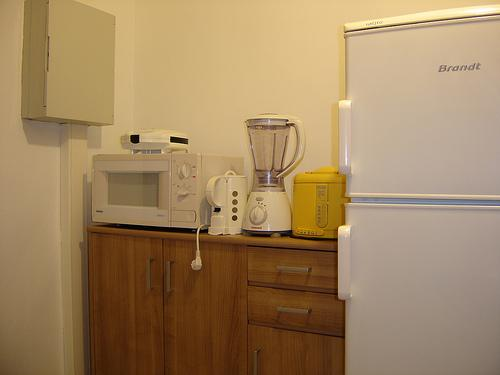Identify three colors prominently found in the image. White, brown, and tan (beige). Describe the appearance and features of the cabinets in the image. The cabinets are brown with drawers and doors, having two white nicely turned handles, and metal handles on the drawers. Tell me about the electrical items associated with the devices in the kitchen. There is a hanging electrical cord, a white cord and plug, a CEE Euro standard plug cable, and a power supply box. Name the appliance on top of the microwave and guess its purpose. A spaceship-shaped waffle maker presumably used for making crepes or waffles. Explain the position of the microwave and blender in relation to each other. The microwave is situated on the countertop, and the blender is next to it on the same countertop. Give a brief summary of the objects in the image, including their colors and arrangement. There are various kitchen appliances such as a white refrigerator, microwave, blender, and coffeemaker; brown cabinets and drawers; a beige-colored wall; a tan electrical box, and a waffle maker on top of the microwave. They are arranged in an organized, functional manner. Which brand is mentioned on the refrigerator and what is the origin of the brand? Brandt is mentioned, which is an older French brand. How many appliances are lined up in a row in the image? Four different appliances are lined up in a row. What kind of appliances can be found in the kitchen area? Refrigerator, microwave oven, blender, coffeemaker, waffle maker, and bread maker. Express your perception of the sentiment portrayed in this image. The image gives a sense of an organized and well-equipped kitchen with multiple appliances, evoking a feeling of functionality and preparedness. Describe the design of the blender found in the image. The blender has a white base with controls and a clear, plastic top portion. What is the function of the wall-mounted box seen in the image? Possibly an electrical box containing fuses for the power supply What appliance can be found on the countertop between the coffee urn and the yellow plastic container? A white and clear blender What is the unique feature of the coffee urn on the counter? It might be some kind of European coffeemaker Describe the design of the refrigerator in the image. The refrigerator is an older French model, Brandt, with two white doors and door handles. In the image provided, read the visible brand name of the appliance. Brandt Which appliance has a waffle maker on top of it? The microwave on the countertop Create a poem that describes the scene in the image. In a kitchen filled with cleanliness bright, Explain the hierarchy and organization of objects in the scene as if you were creating a diagram for someone. The kitchen scene contains several objects: a white two-door refrigerator is at the left, a microwave sits on a countertop with a waffle maker on top, cabinets with drawers surround it, a blender and coffee urn are on the counter, and an electrical box is mounted on the wall. Which of the following French brand appliances can be found in the kitchen image? a) KitchenAid b) Whirlpool c) Brandt d) Samsung c) Brandt Could you identify any event happening in the image? No events are happening; it's just a kitchen with appliances. Describe the scene depicted in the image with respect to the arrangement of appliances in the kitchen. The kitchen features various appliances including a refrigerator, cabinets, a blender, a coffee urn, a microwave, and a yellow plastic container, all lined up along the counter. What is the color of the cabinet doors? Brown 